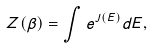<formula> <loc_0><loc_0><loc_500><loc_500>Z ( \beta ) = \int e ^ { J ( E ) } d E ,</formula> 